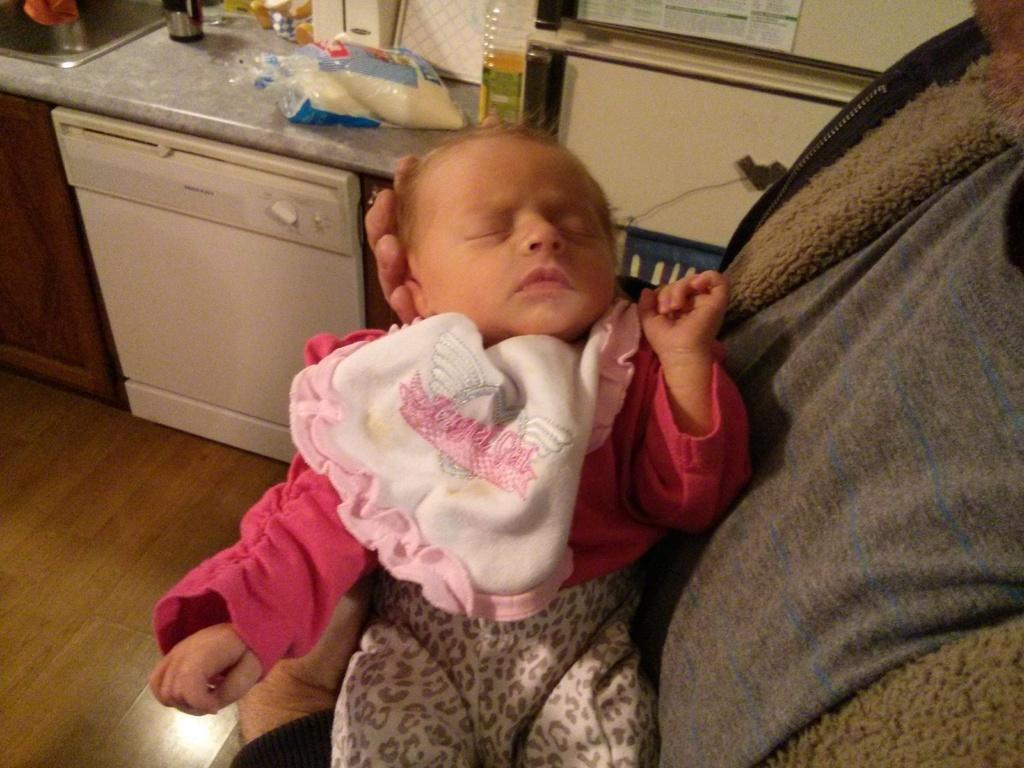What is the person in the image doing? The person is holding a baby in the image. What can be seen on the shelf in the image? There are objects on a shelf in the image. What type of items are present in the image? Electronic gadgets are present in the image. What is visible in the background of the image? There is a wall visible in the image. What type of noise can be heard coming from the picture in the image? There is no picture present in the image, and therefore no noise can be heard coming from it. 